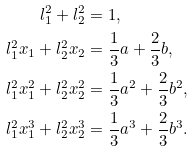Convert formula to latex. <formula><loc_0><loc_0><loc_500><loc_500>l ^ { 2 } _ { 1 } + l ^ { 2 } _ { 2 } & = 1 , \\ l ^ { 2 } _ { 1 } x _ { 1 } + l ^ { 2 } _ { 2 } x _ { 2 } & = \frac { 1 } { 3 } a + \frac { 2 } { 3 } b , \\ l ^ { 2 } _ { 1 } x ^ { 2 } _ { 1 } + l ^ { 2 } _ { 2 } x ^ { 2 } _ { 2 } & = \frac { 1 } { 3 } a ^ { 2 } + \frac { 2 } { 3 } b ^ { 2 } , \\ l ^ { 2 } _ { 1 } x ^ { 3 } _ { 1 } + l ^ { 2 } _ { 2 } x ^ { 3 } _ { 2 } & = \frac { 1 } { 3 } a ^ { 3 } + \frac { 2 } { 3 } b ^ { 3 } .</formula> 